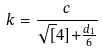<formula> <loc_0><loc_0><loc_500><loc_500>k = \frac { c } { \sqrt { [ } 4 ] { + \frac { d _ { 1 } } { 6 } } }</formula> 